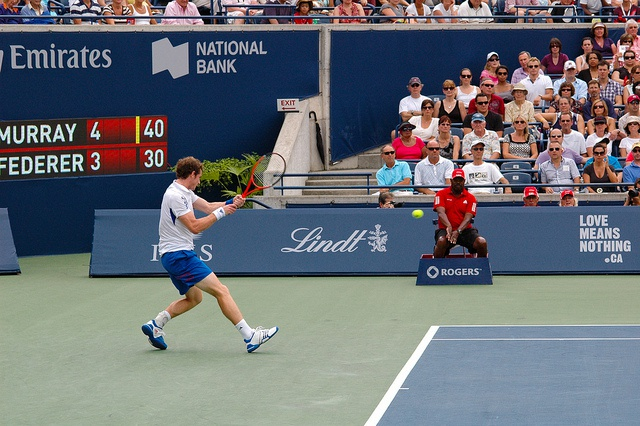Describe the objects in this image and their specific colors. I can see people in salmon, black, darkgray, brown, and lightgray tones, people in salmon, lavender, darkgray, brown, and black tones, people in salmon, black, brown, maroon, and red tones, people in salmon, lightblue, and brown tones, and people in salmon, darkgray, brown, and lavender tones in this image. 